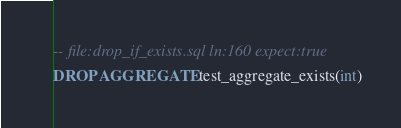<code> <loc_0><loc_0><loc_500><loc_500><_SQL_>-- file:drop_if_exists.sql ln:160 expect:true
DROP AGGREGATE test_aggregate_exists(int)
</code> 